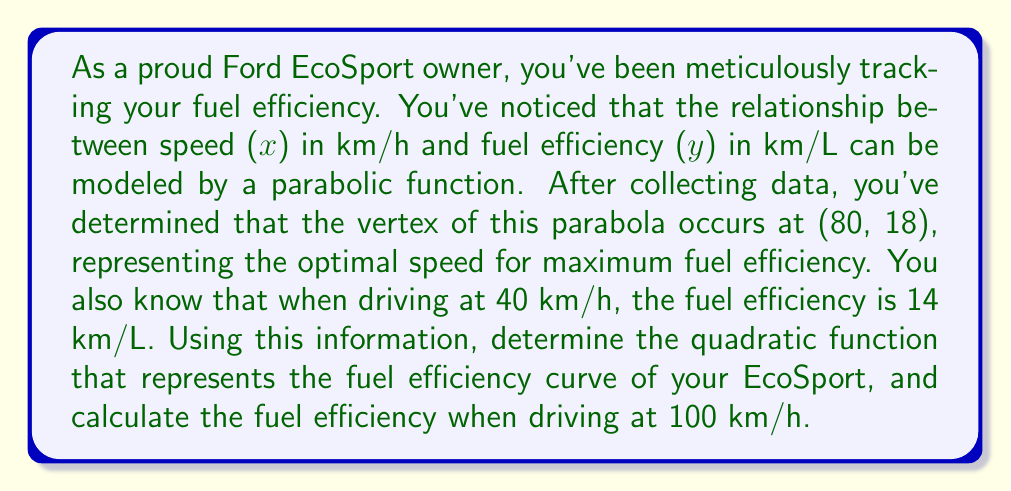Give your solution to this math problem. Let's approach this step-by-step:

1) The general form of a quadratic function with vertex (h, k) is:
   $$ y = a(x - h)^2 + k $$
   Where (h, k) is (80, 18) in this case.

2) Substituting the vertex:
   $$ y = a(x - 80)^2 + 18 $$

3) We know another point on the curve: (40, 14). Let's use this to find 'a':
   $$ 14 = a(40 - 80)^2 + 18 $$
   $$ 14 = a(-40)^2 + 18 $$
   $$ 14 = 1600a + 18 $$
   $$ -4 = 1600a $$
   $$ a = -\frac{1}{400} = -0.0025 $$

4) Now we have our complete quadratic function:
   $$ y = -0.0025(x - 80)^2 + 18 $$

5) To find the fuel efficiency at 100 km/h, we substitute x = 100:
   $$ y = -0.0025(100 - 80)^2 + 18 $$
   $$ y = -0.0025(20)^2 + 18 $$
   $$ y = -0.0025(400) + 18 $$
   $$ y = -1 + 18 = 17 $$

Therefore, at 100 km/h, the fuel efficiency is 17 km/L.
Answer: $y = -0.0025(x - 80)^2 + 18$; 17 km/L at 100 km/h 